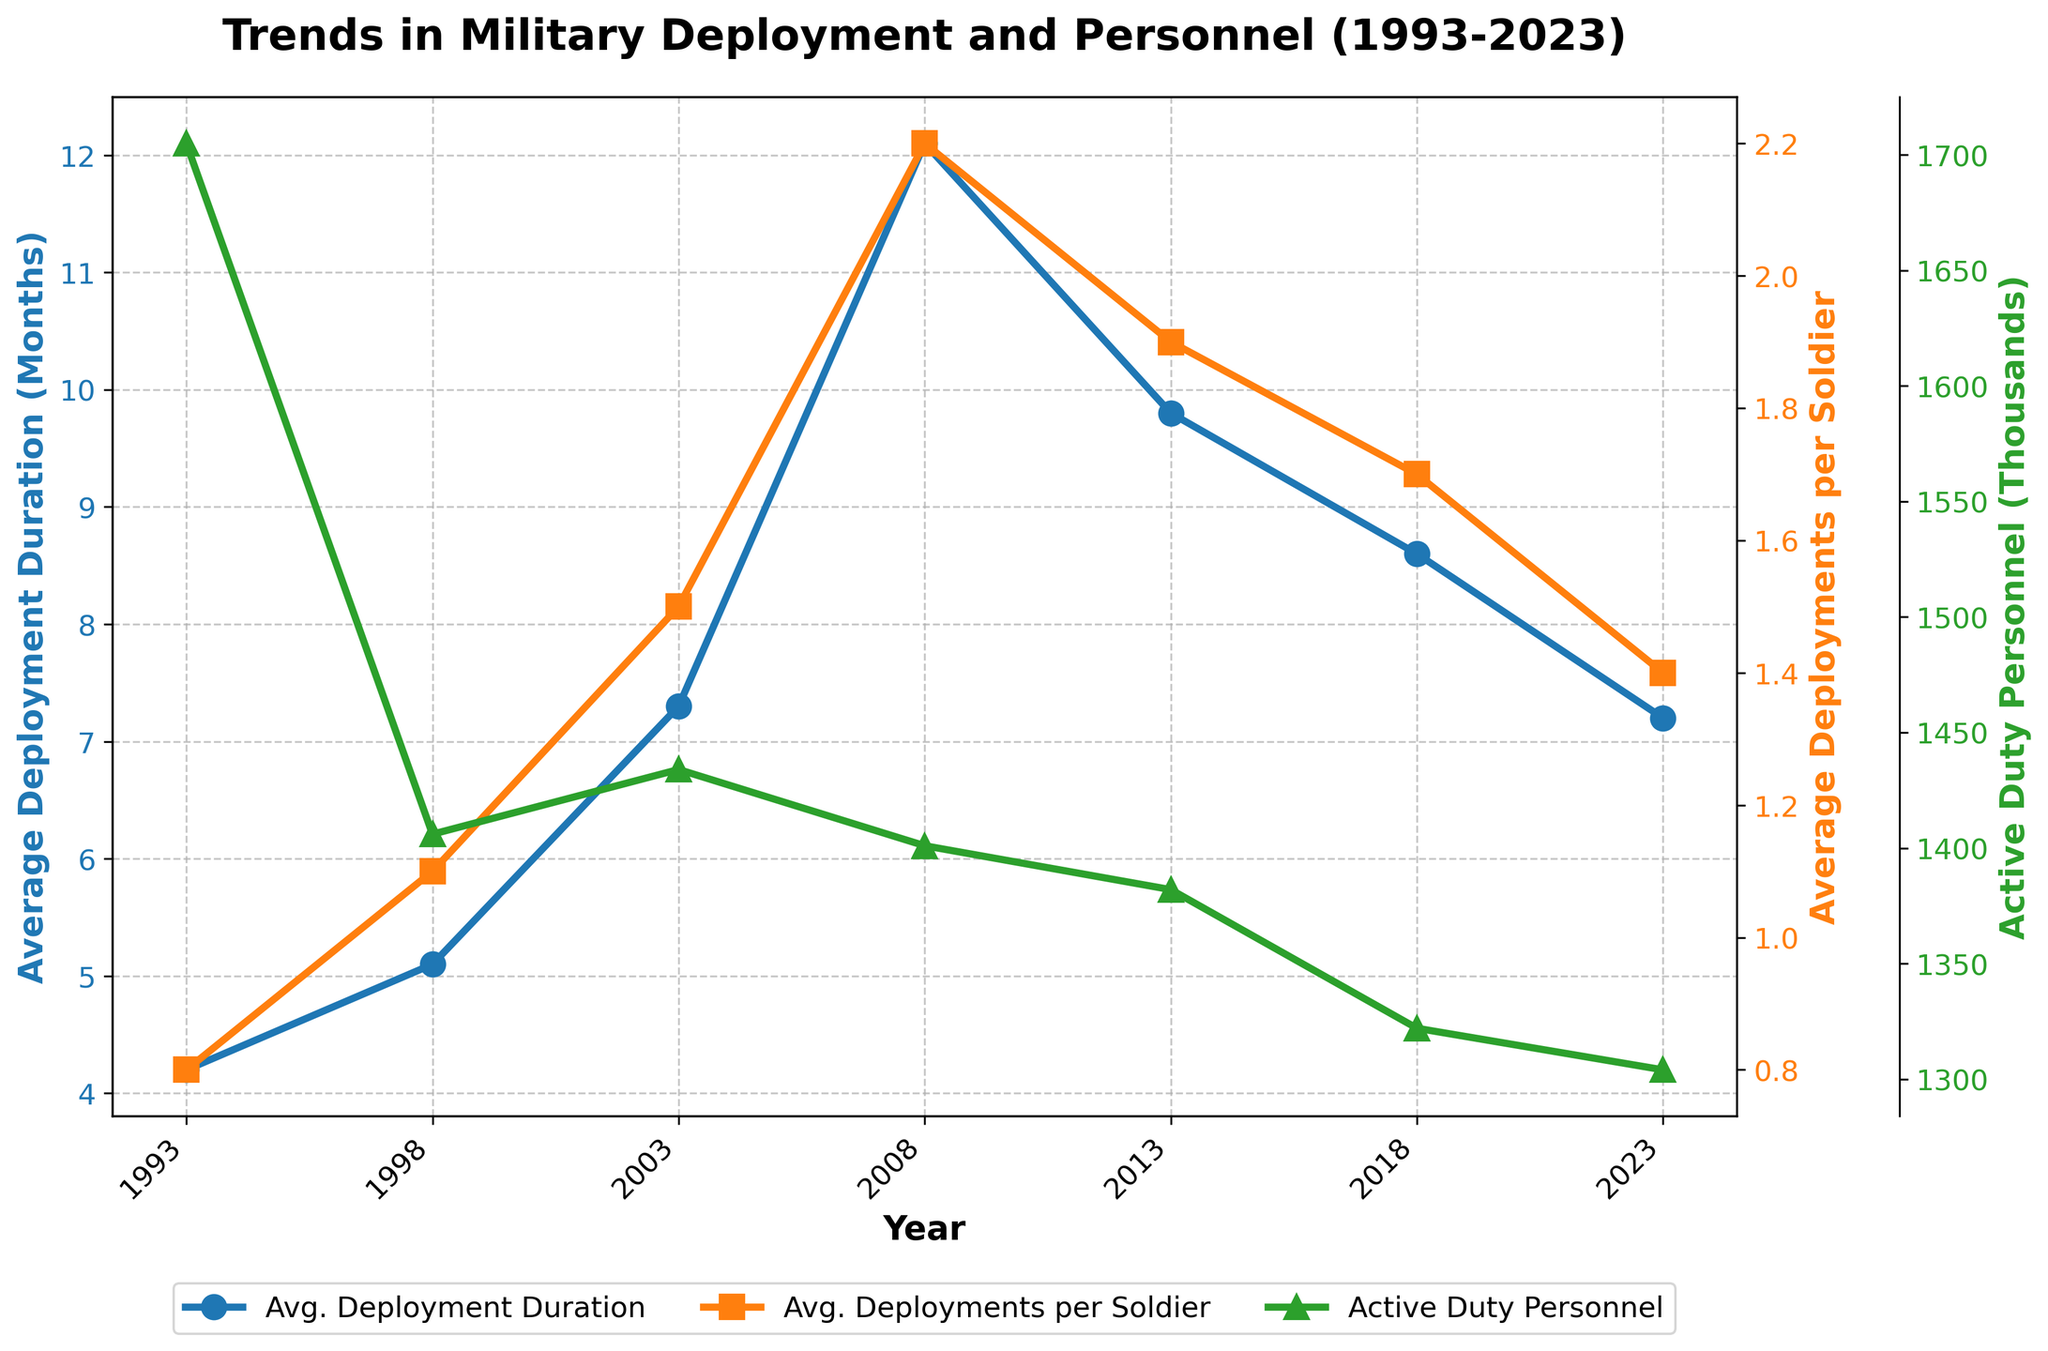What's the average duration of deployments in 2003? Look for the point on the blue line (Average Deployment Duration) in the year 2003. The value is 7.3 months.
Answer: 7.3 months How many deployments did the average soldier have in 2018? Refer to the orange line (Average Deployments per Soldier) in the year 2018. The value is 1.7.
Answer: 1.7 Which year had the highest average deployment duration? Check the highest point on the blue line. It occurs in 2008 with a value of 12.1 months.
Answer: 2008 What is the trend in active duty personnel between 2013 and 2023? Examine the green line segment between 2013 and 2023. It shows a decrease in active duty personnel from 1382 thousand to 1304 thousand.
Answer: Decreasing Compare the average deployments per soldier in 2003 and 2013. Which year had more? Look at the orange line for the values in 2003 (1.5) and 2013 (1.9). 2013 had more deployments per soldier.
Answer: 2013 Between 1993 and 2003, how did the average deployment duration change? Observe the blue line from 1993 to 2003. The value increases from 4.2 months to 7.3 months, indicating an increase.
Answer: Increased What is the difference in active duty personnel between 1993 and 2018? Find the values on the green line for 1993 (1705 thousand) and 2018 (1322 thousand). The difference is 1705 - 1322 = 383 thousand.
Answer: 383 thousand How does the average deployment duration in 2023 compare to 2008? Look at the blue line values for 2023 (7.2 months) and 2008 (12.1 months). The duration has decreased.
Answer: Decreased Which year saw the highest average deployments per soldier? Identify the highest point on the orange line, which occurs in 2008, with a value of 2.2 deployments.
Answer: 2008 What is the trend in the average deployment duration after 2008? Examine the blue line after 2008. The trend shows a decrease from 12.1 months in 2008 to 7.2 months in 2023.
Answer: Decreasing 